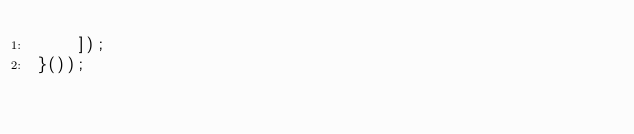Convert code to text. <code><loc_0><loc_0><loc_500><loc_500><_JavaScript_>    ]);
}());</code> 